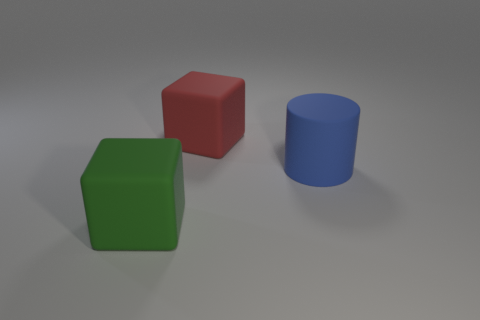There is a big thing on the right side of the large cube that is on the right side of the big thing in front of the large blue matte thing; what is it made of?
Your answer should be compact. Rubber. There is a cylinder that is made of the same material as the big red thing; what is its size?
Make the answer very short. Large. Is there any other thing that is the same color as the cylinder?
Your answer should be compact. No. There is a large block that is behind the cylinder; is its color the same as the big object in front of the big cylinder?
Ensure brevity in your answer.  No. What color is the block that is behind the green cube?
Ensure brevity in your answer.  Red. There is a rubber thing that is left of the red block; is its size the same as the big red cube?
Ensure brevity in your answer.  Yes. Is the number of cyan matte cylinders less than the number of green objects?
Your answer should be very brief. Yes. There is a green block; how many blue matte cylinders are right of it?
Keep it short and to the point. 1. Is the green matte thing the same shape as the red thing?
Your response must be concise. Yes. How many matte objects are both behind the green rubber cube and left of the big blue thing?
Keep it short and to the point. 1. 